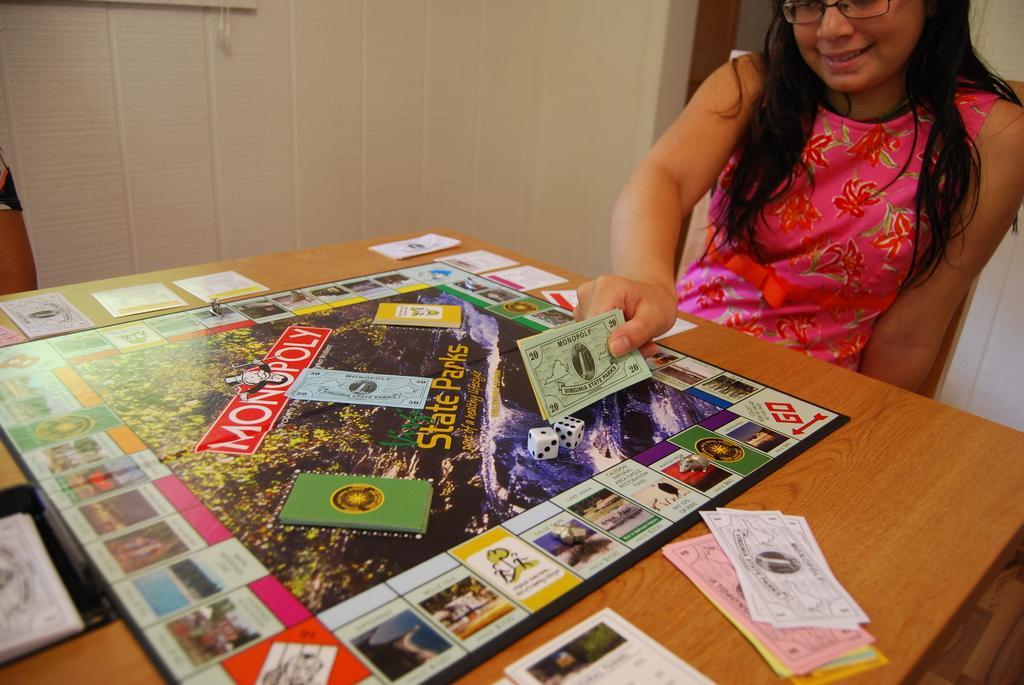Could you give a brief overview of what you see in this image? In this picture we can see a woman wore spectacles, smiling, holding papers with her hand and in front of her we can see a game board, papers on the table and in the background we can see the wall. 